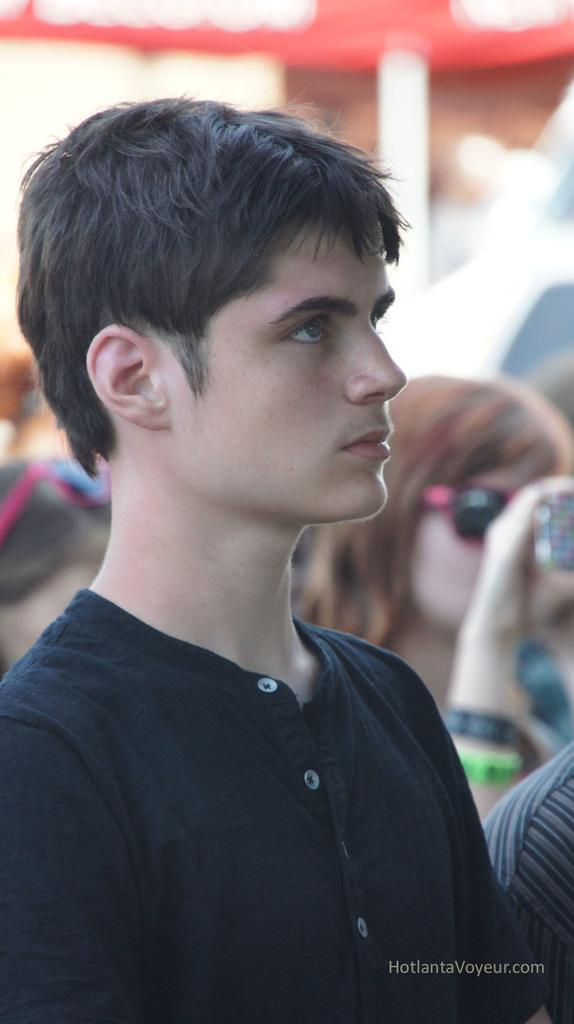How many people are in the image? There are people in the image, but the exact number is not specified. What is the man wearing in the image? The man is wearing black color clothes in the image. Can you describe the background of the image? The background of the image is blurred. Is there any additional mark or symbol in the image? Yes, there is a watermark in the image. What type of bread can be seen being processed by the machine in the image? There is no bread or machine present in the image. 